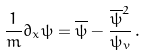<formula> <loc_0><loc_0><loc_500><loc_500>\frac { 1 } { m } \partial _ { x } \psi = \overline { \psi } - \frac { \overline { \psi } ^ { 2 } } { \psi _ { v } } \, .</formula> 